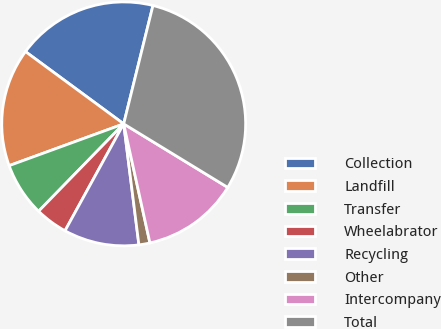Convert chart to OTSL. <chart><loc_0><loc_0><loc_500><loc_500><pie_chart><fcel>Collection<fcel>Landfill<fcel>Transfer<fcel>Wheelabrator<fcel>Recycling<fcel>Other<fcel>Intercompany<fcel>Total<nl><fcel>18.76%<fcel>15.66%<fcel>7.14%<fcel>4.3%<fcel>9.98%<fcel>1.46%<fcel>12.82%<fcel>29.86%<nl></chart> 